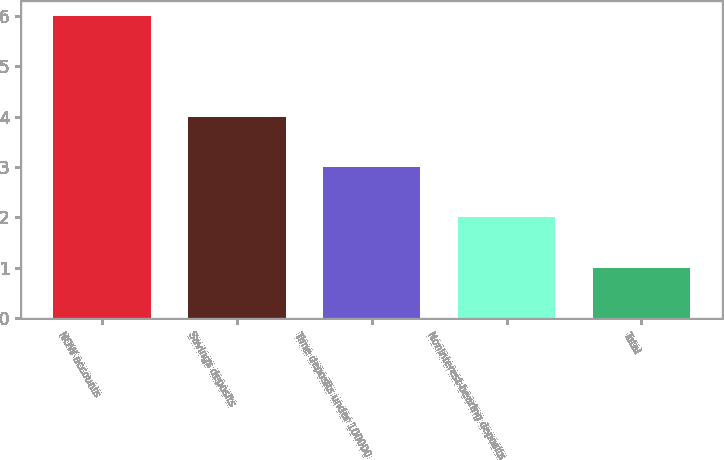Convert chart to OTSL. <chart><loc_0><loc_0><loc_500><loc_500><bar_chart><fcel>NOW accounts<fcel>Savings deposits<fcel>Time deposits under 100000<fcel>Noninterest-bearing deposits<fcel>Total<nl><fcel>6<fcel>4<fcel>3<fcel>2<fcel>1<nl></chart> 